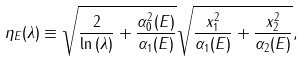Convert formula to latex. <formula><loc_0><loc_0><loc_500><loc_500>\eta _ { E } ( \lambda ) \equiv \sqrt { \frac { 2 } { \ln { ( \lambda ) } } + \frac { \alpha _ { 0 } ^ { 2 } ( E ) } { \alpha _ { 1 } ( E ) } } \sqrt { \frac { x _ { 1 } ^ { 2 } } { \alpha _ { 1 } ( E ) } + \frac { x _ { 2 } ^ { 2 } } { \alpha _ { 2 } ( E ) } } ,</formula> 